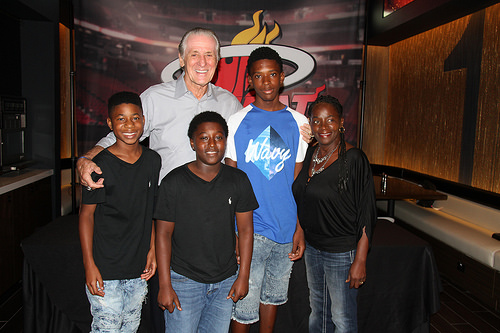<image>
Is the boy next to the woman? Yes. The boy is positioned adjacent to the woman, located nearby in the same general area. 